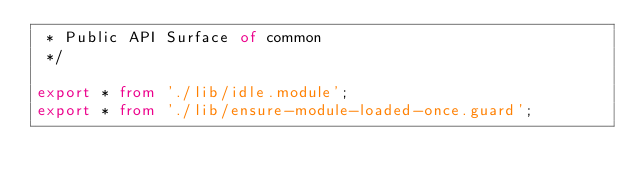<code> <loc_0><loc_0><loc_500><loc_500><_TypeScript_> * Public API Surface of common
 */

export * from './lib/idle.module';
export * from './lib/ensure-module-loaded-once.guard';
</code> 